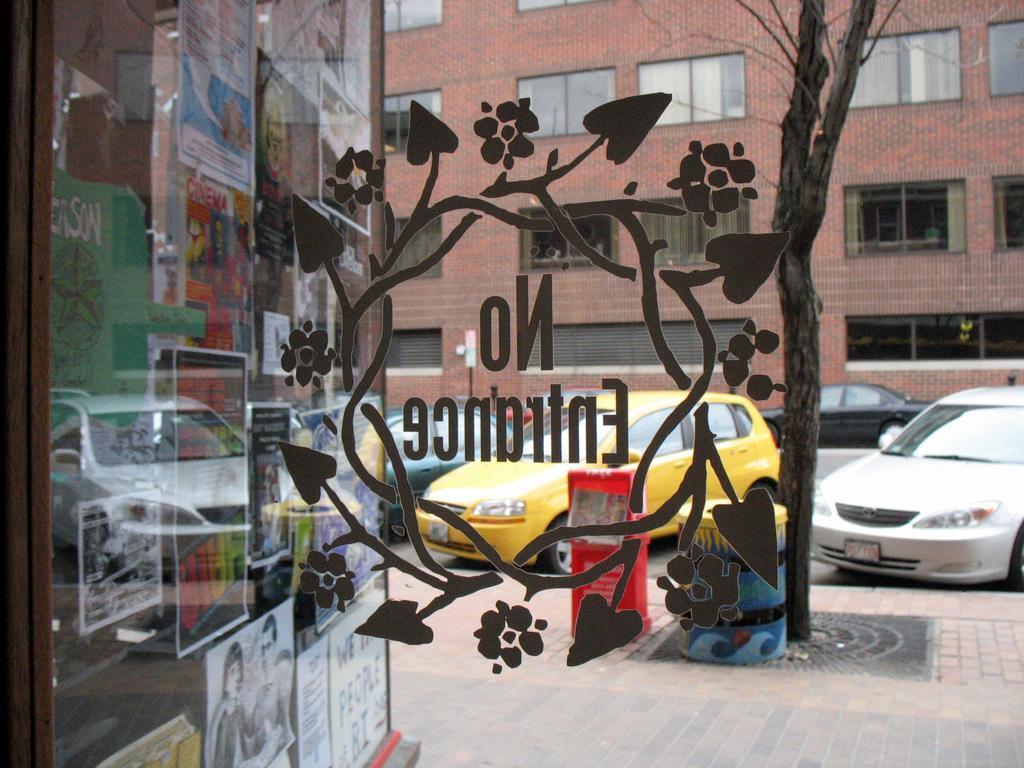Can you describe this image briefly? In this picture there is a text on the mirror. Behind the mirror there are vehicles on the road and there is a tree and dustbin on the footpath and there is a building. On the left side of the image there are posters on the mirror. 